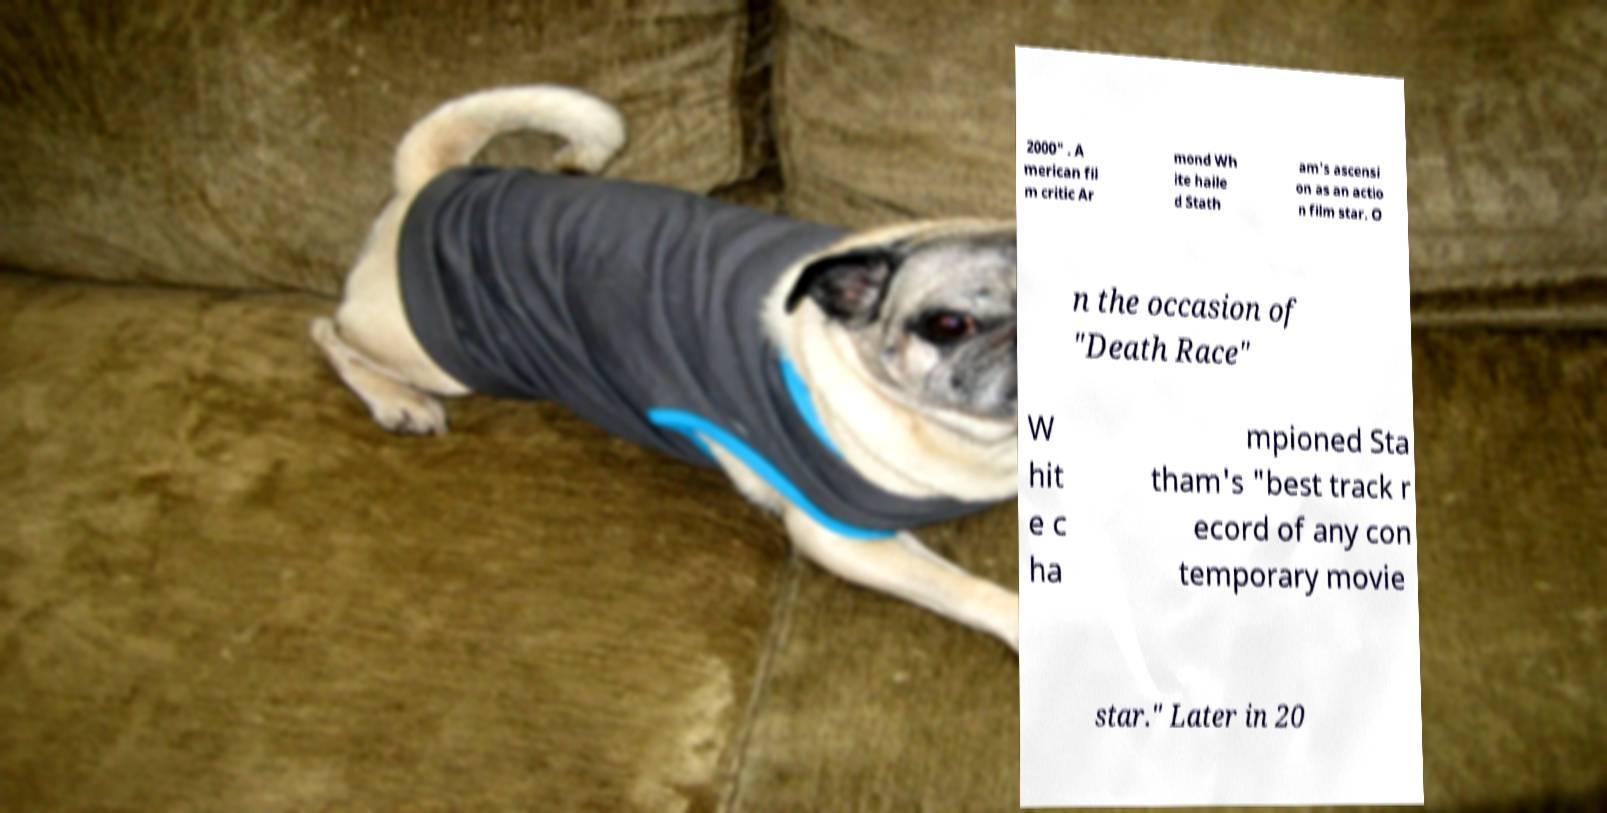For documentation purposes, I need the text within this image transcribed. Could you provide that? 2000" . A merican fil m critic Ar mond Wh ite haile d Stath am's ascensi on as an actio n film star. O n the occasion of "Death Race" W hit e c ha mpioned Sta tham's "best track r ecord of any con temporary movie star." Later in 20 